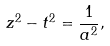<formula> <loc_0><loc_0><loc_500><loc_500>z ^ { 2 } - t ^ { 2 } = \frac { 1 } { a ^ { 2 } } ,</formula> 